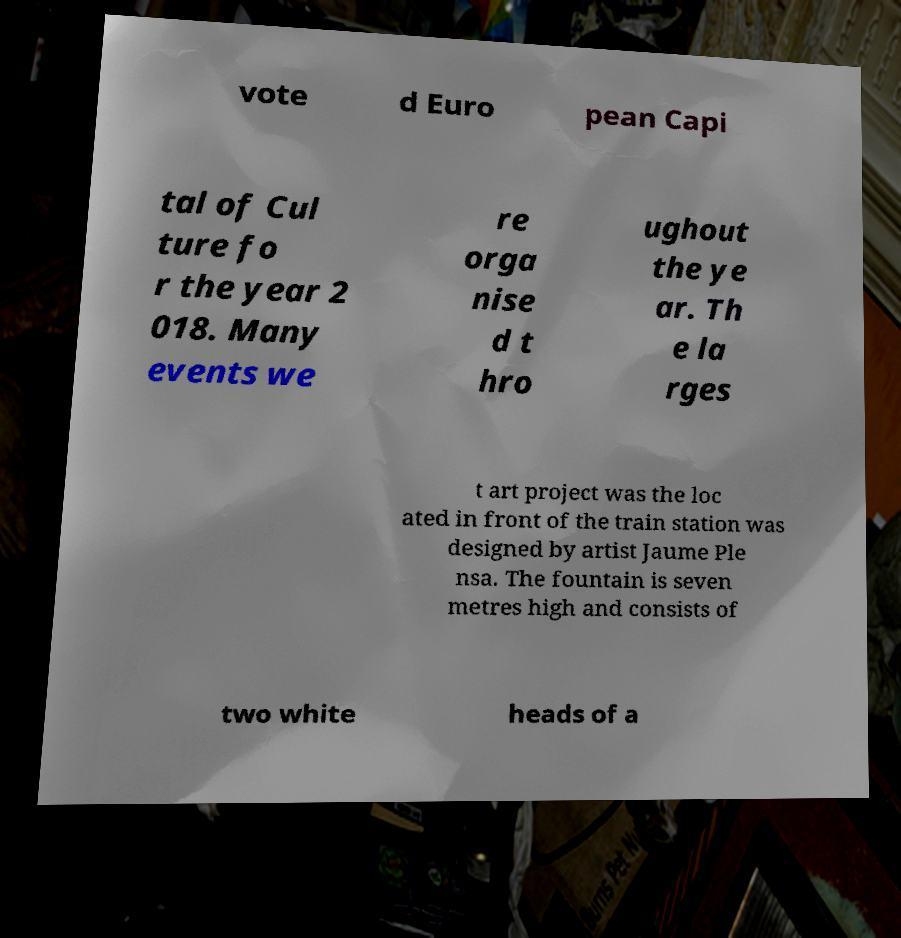What messages or text are displayed in this image? I need them in a readable, typed format. vote d Euro pean Capi tal of Cul ture fo r the year 2 018. Many events we re orga nise d t hro ughout the ye ar. Th e la rges t art project was the loc ated in front of the train station was designed by artist Jaume Ple nsa. The fountain is seven metres high and consists of two white heads of a 